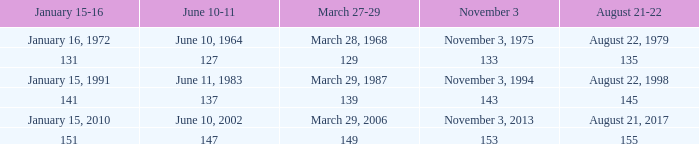What is shown for  august 21-22 when november 3 is november 3, 1994? August 22, 1998. 